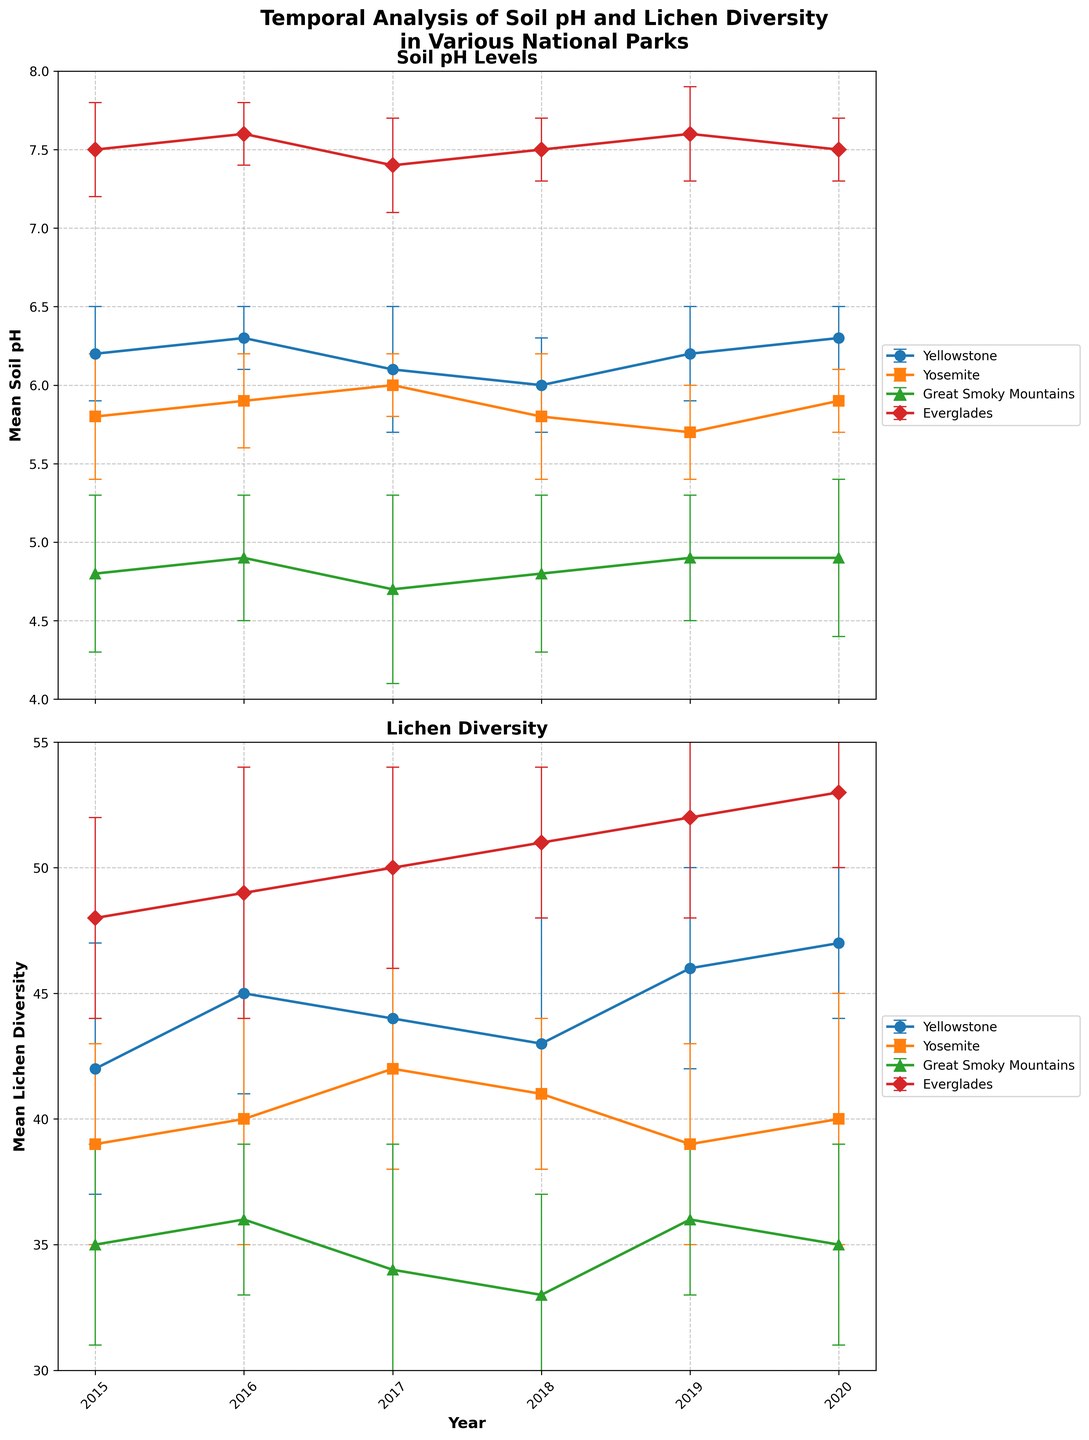What is the range of years shown in the figure? The x-axis of the plots shows the range of years. The starting point is 2015 and the ending point is 2020, so the range is from 2015 to 2020.
Answer: 2015 to 2020 Which park shows the highest mean soil pH level across the observed years? In the soil pH plot, the Everglades consistently has the highest mean soil pH levels compared to the other parks.
Answer: Everglades Does Yosemite show an increasing trend in lichen diversity from 2015 to 2020? In the lichen diversity plot, Yosemite's data points start at a mean lichen diversity of 39 in 2015 and fluctuate slightly over the years, ending at 40 in 2020. There is no clear increasing trend.
Answer: No Which park has the highest variability in soil pH throughout the years? The error bars indicate variability. Great Smoky Mountains (with larger error bars) consistently show higher standard deviations in soil pH compared to other parks.
Answer: Great Smoky Mountains What is the mean lichen diversity in Yellowstone for the year 2019? In the lichen diversity plot, locate the data point for Yellowstone corresponding to the year 2019, which shows a mean lichen diversity of 46.
Answer: 46 How does the mean soil pH in the Everglades change from 2018 to 2019? In the soil pH plot, locate the data points for the Everglades for the years 2018 and 2019. In 2018, it's 7.5 and in 2019, it's 7.6, showing an increase.
Answer: It increases from 7.5 to 7.6 Compare the mean lichen diversity in Yosemite and Great Smoky Mountains for the year 2017. Which park has higher diversity? In the lichen diversity plot for 2017, Yosemite shows a mean lichen diversity of 42 while Great Smoky Mountains shows 34, indicating that Yosemite has the higher diversity.
Answer: Yosemite Is there any year where Yellowstone and Yosemite have the same mean soil pH? Observing the soil pH plot, Yellowstone and Yosemite do not have any overlapping points for mean soil pH in the same year.
Answer: No Which park shows the most consistent mean soil pH levels over the years? Look for the park with the smallest changes in its mean soil pH levels over the observed years. Yellowstone and Everglades have very small changes, but Everglades has the smallest variation.
Answer: Everglades 